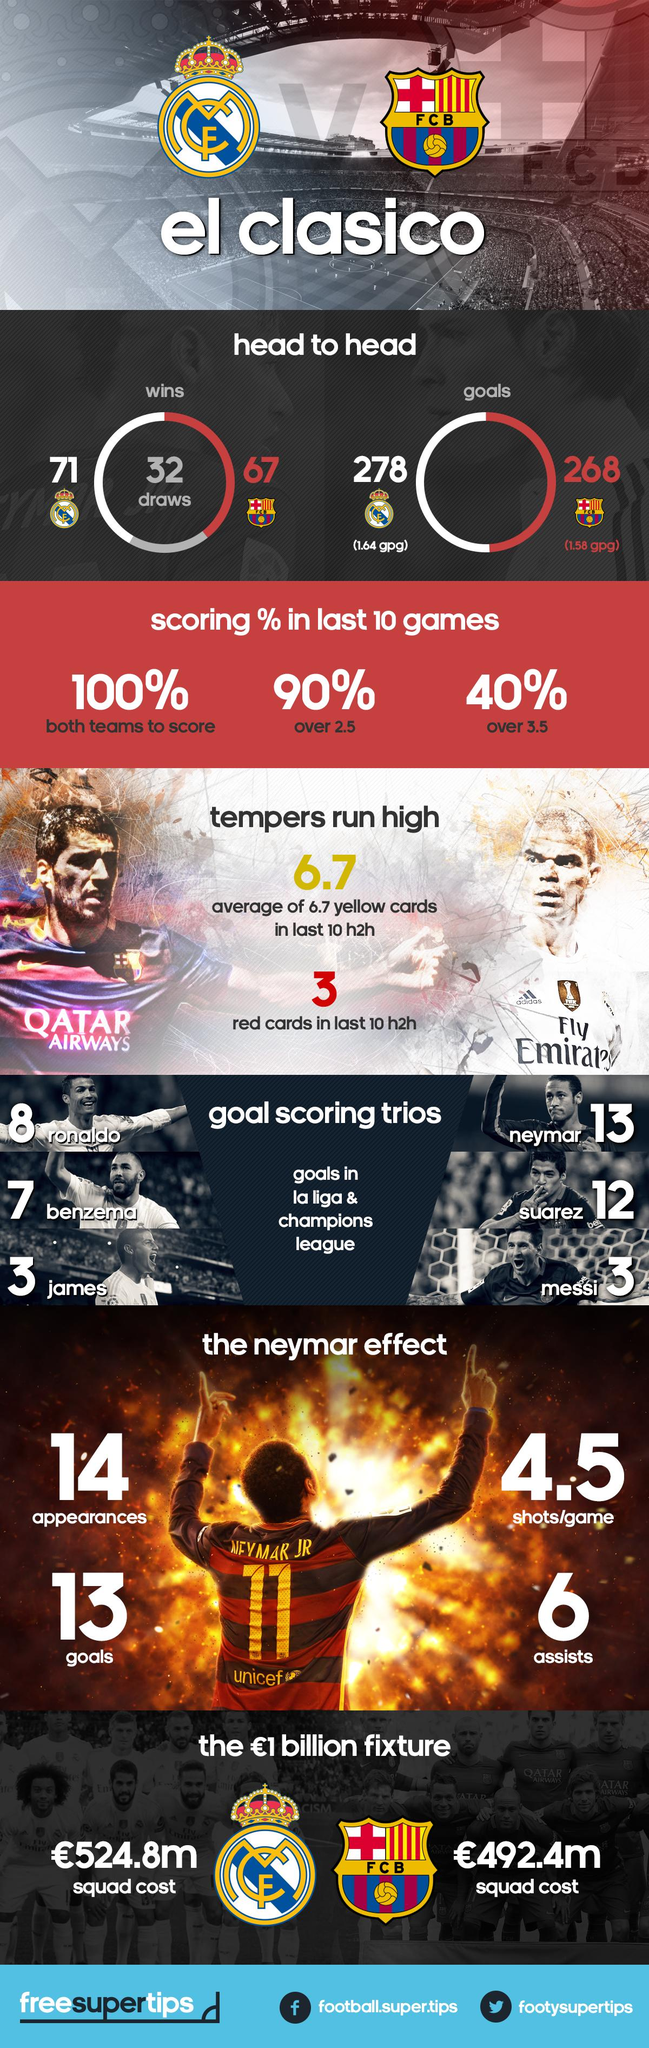Indicate a few pertinent items in this graphic. The highest-scoring trio in Real Madrid C.F. history, excluding Benzema, consists of Ronaldo and James. Barcelona FC's jersey bears the inscription 'QATAR AIRWAYS,' signifying the club's partnership with the leading airline in the region. F.C. Barcelona holds the highest number of victories in the rivalry between the two teams that compete in the El Clásico. Barcelona FC has won El Clásico 67 times. In "El Clasico," Real Madrid C.F. scored a total of 278 goals. 